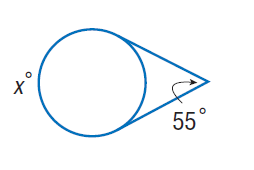Question: Find x.
Choices:
A. 55
B. 110
C. 125
D. 235
Answer with the letter. Answer: D 